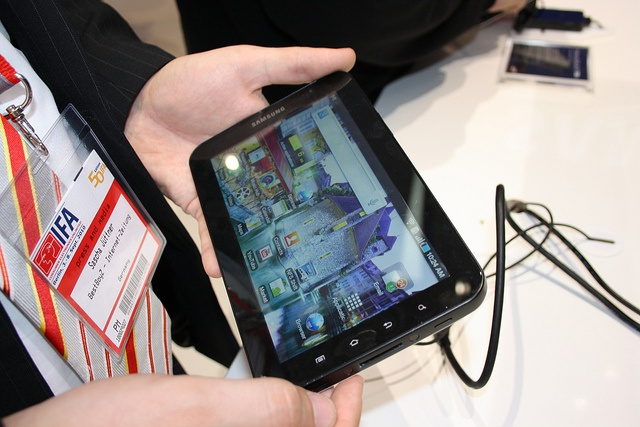Describe the objects in this image and their specific colors. I can see people in black, lightpink, lightgray, and darkgray tones, cell phone in black and gray tones, tie in black, darkgray, lightgray, and red tones, and cell phone in black, gray, darkgray, and lightgray tones in this image. 